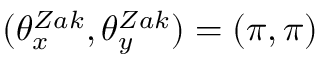<formula> <loc_0><loc_0><loc_500><loc_500>( \theta _ { x } ^ { Z a k } , \theta _ { y } ^ { Z a k } ) = ( \pi , \pi )</formula> 